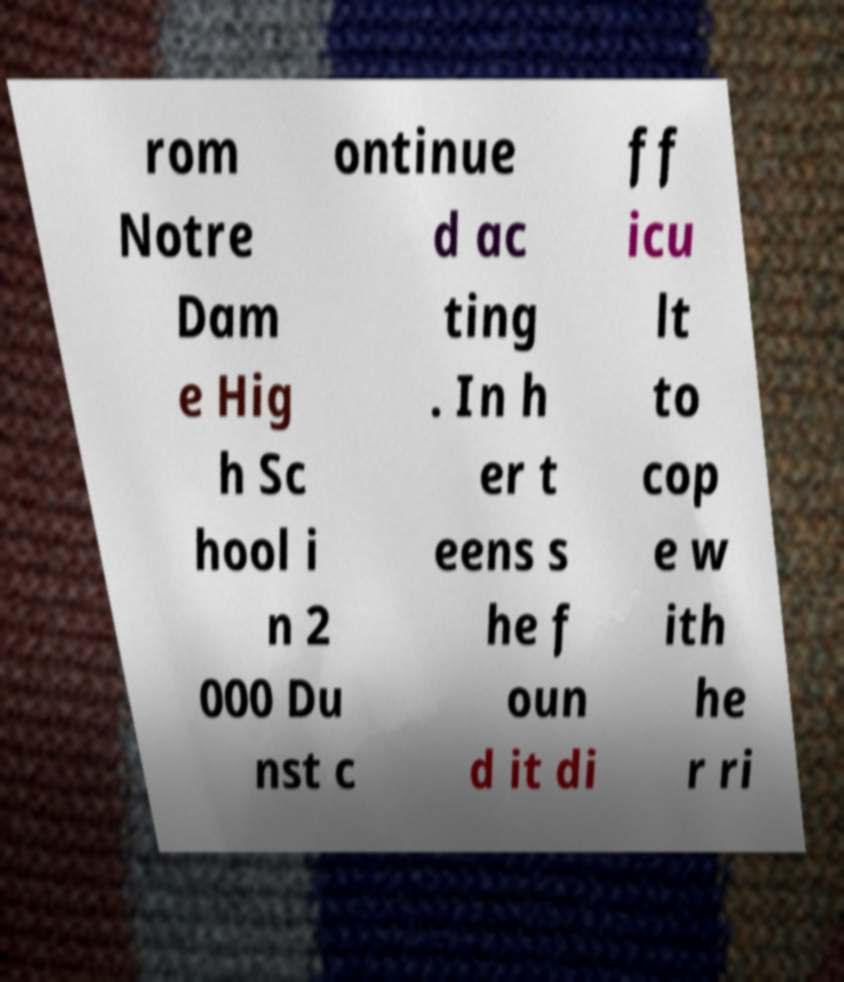Can you accurately transcribe the text from the provided image for me? rom Notre Dam e Hig h Sc hool i n 2 000 Du nst c ontinue d ac ting . In h er t eens s he f oun d it di ff icu lt to cop e w ith he r ri 